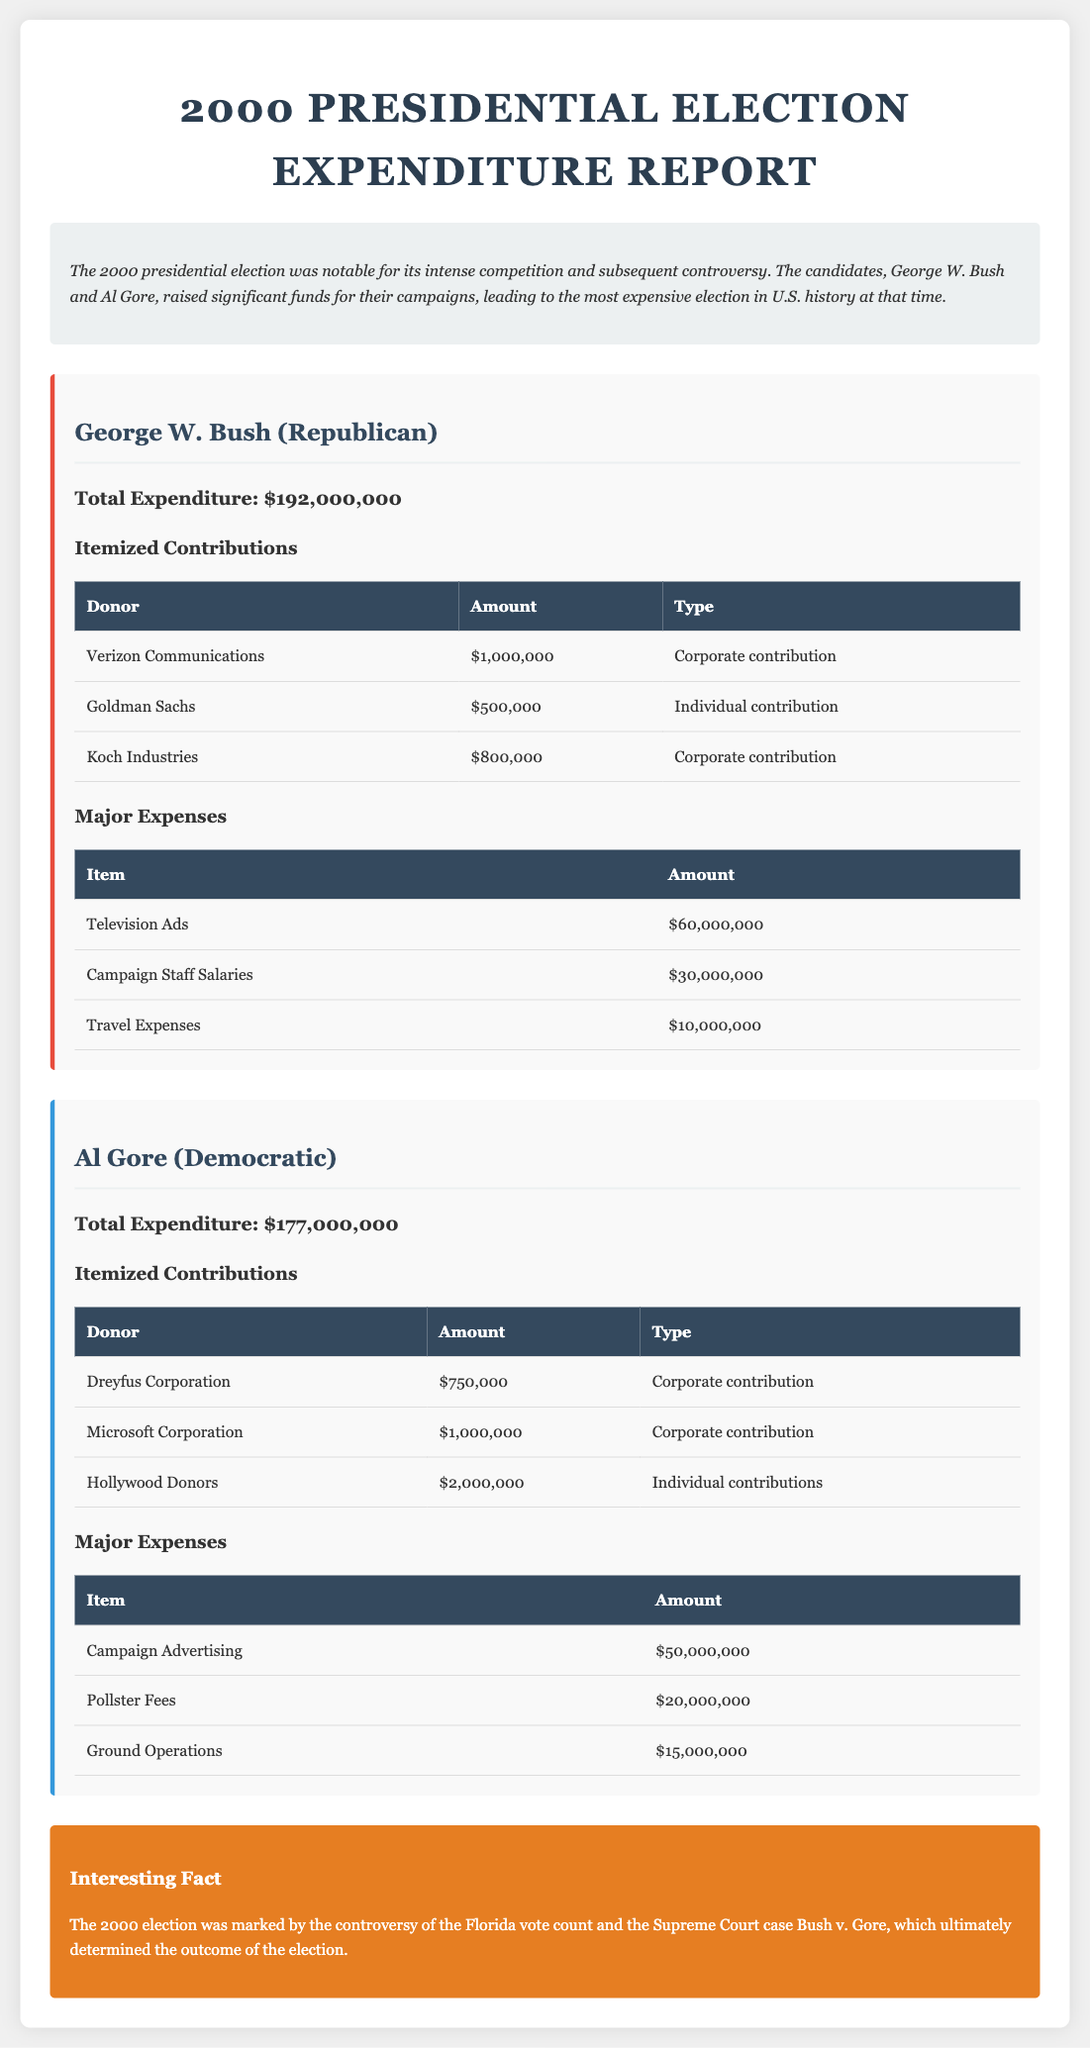total expenditure for George W. Bush The total expenditure for George W. Bush can be found in his section, which states it is $192,000,000.
Answer: $192,000,000 highest individual contribution for Al Gore Al Gore's highest individual contribution is from Hollywood Donors, which is $2,000,000.
Answer: $2,000,000 major expense for George W. Bush The major expense for George W. Bush is Television Ads, amounting to $60,000,000.
Answer: Television Ads total amount contributed by Verizon Communications The contribution from Verizon Communications is listed as $1,000,000.
Answer: $1,000,000 total expenses for Al Gore The total expenses for Al Gore are recorded as $177,000,000.
Answer: $177,000,000 which candidate had higher total expenditure Comparing the total expenditures, George W. Bush had a higher total expenditure than Al Gore.
Answer: George W. Bush source of interesting fact The interesting fact section mentions the controversy surrounding the Florida vote count and the Supreme Court case Bush v. Gore.
Answer: Bush v. Gore amount spent on Campaign Advertising by Al Gore The amount spent by Al Gore on Campaign Advertising is noted as $50,000,000.
Answer: $50,000,000 type of contribution by Koch Industries for George W. Bush Koch Industries made a corporate contribution to George W. Bush.
Answer: Corporate contribution 